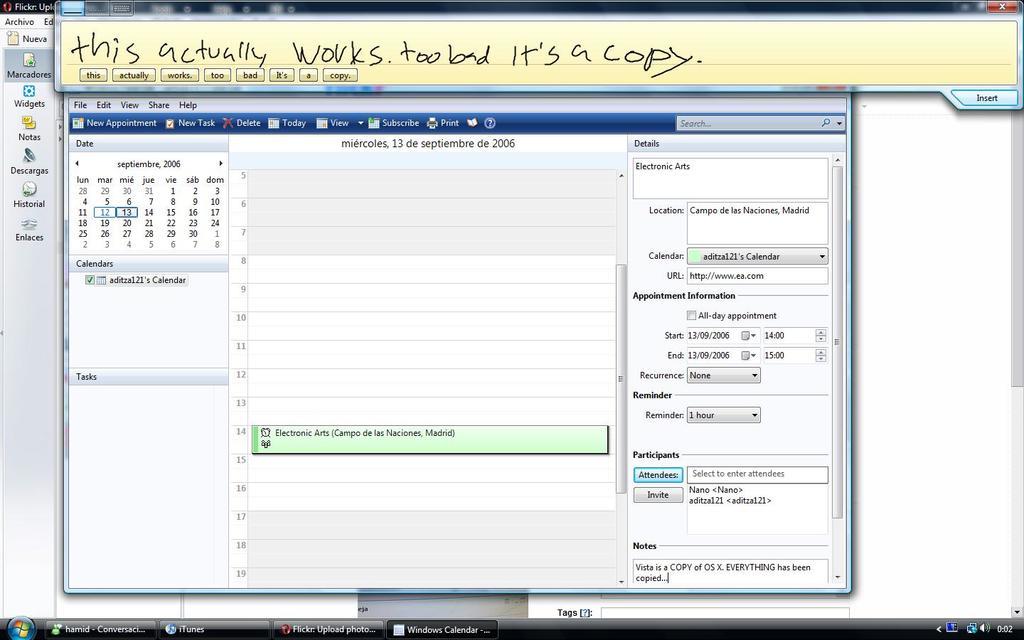Does it say if this actually works?
Your response must be concise. Yes. What is the time on the computer?
Offer a very short reply. Unanswerable. 